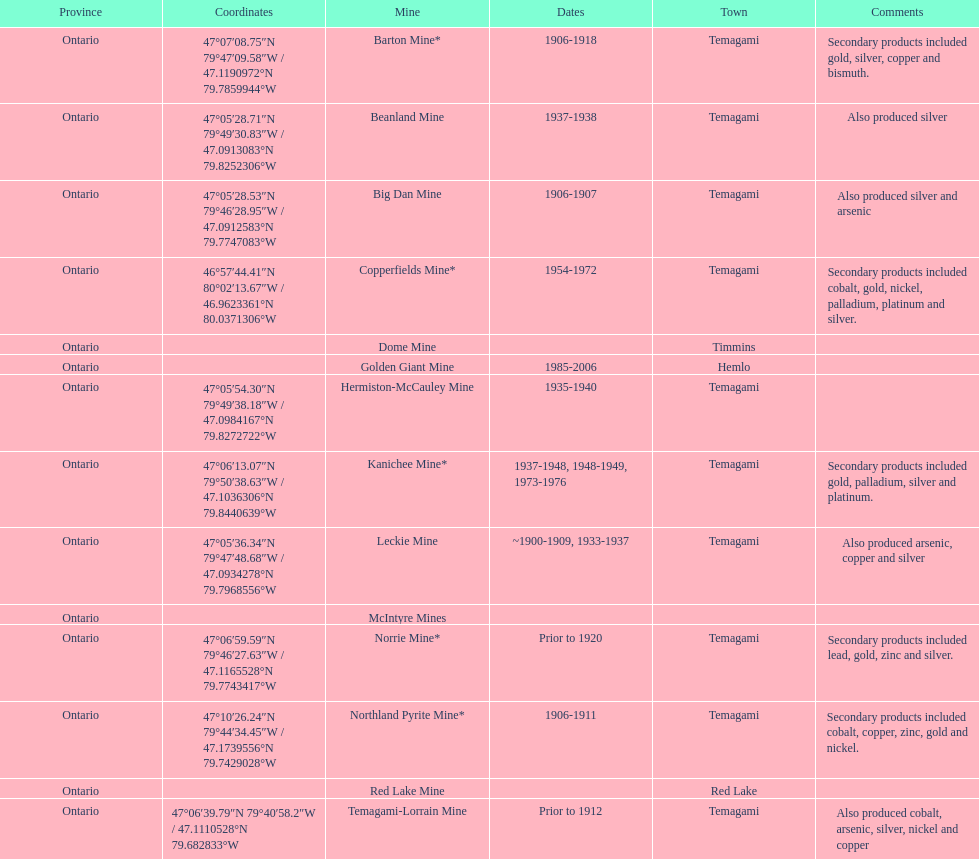Name a gold mine that was open at least 10 years. Barton Mine. 